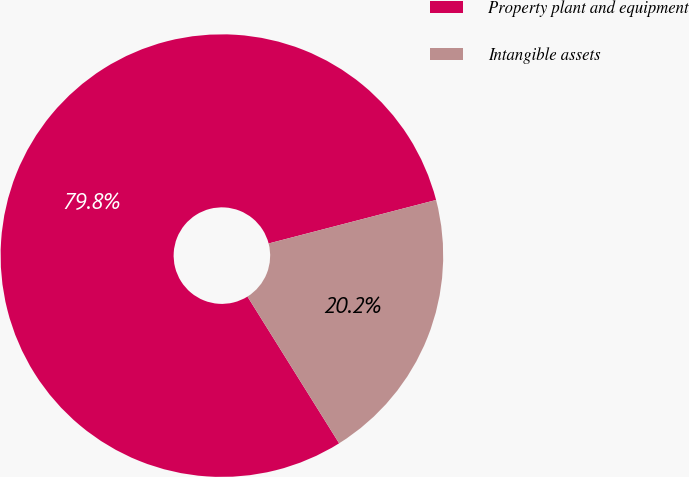<chart> <loc_0><loc_0><loc_500><loc_500><pie_chart><fcel>Property plant and equipment<fcel>Intangible assets<nl><fcel>79.84%<fcel>20.16%<nl></chart> 